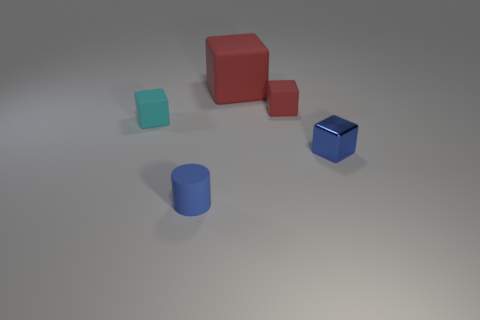Are there more metallic cubes that are right of the large thing than tiny cubes?
Provide a succinct answer. No. How many small red rubber objects are right of the small blue matte object?
Make the answer very short. 1. Are there any matte cylinders that have the same size as the cyan block?
Give a very brief answer. Yes. There is a tiny shiny object that is the same shape as the large red thing; what color is it?
Keep it short and to the point. Blue. Is the size of the matte thing that is to the right of the large red rubber cube the same as the red block that is behind the small red cube?
Your response must be concise. No. Is there a big gray rubber thing of the same shape as the tiny blue matte object?
Provide a succinct answer. No. Is the number of small rubber objects to the right of the matte cylinder the same as the number of blue shiny things?
Give a very brief answer. Yes. There is a metallic thing; does it have the same size as the rubber object that is in front of the small cyan block?
Make the answer very short. Yes. What number of small red cubes are the same material as the cylinder?
Provide a short and direct response. 1. Is the size of the blue block the same as the cyan block?
Offer a very short reply. Yes. 